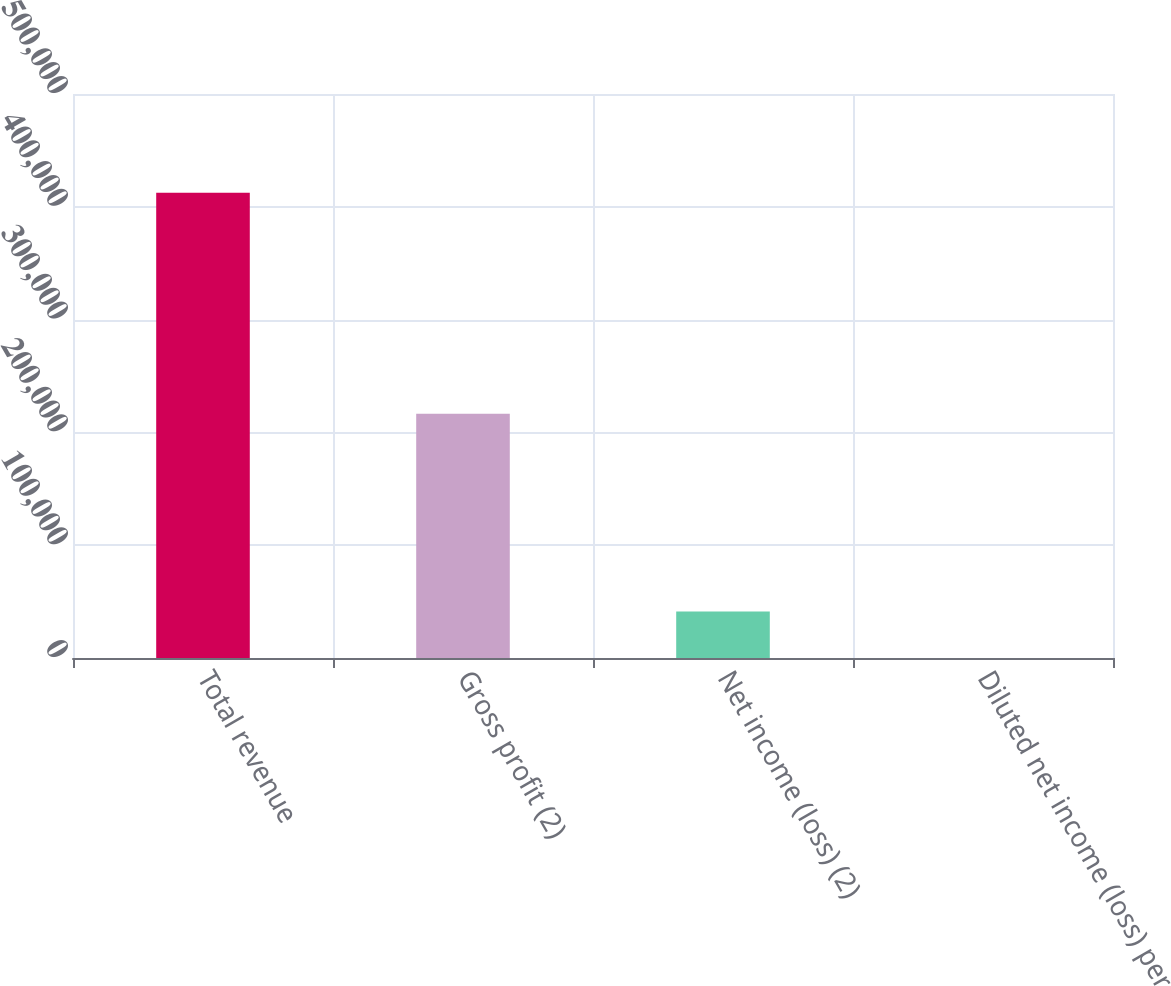Convert chart to OTSL. <chart><loc_0><loc_0><loc_500><loc_500><bar_chart><fcel>Total revenue<fcel>Gross profit (2)<fcel>Net income (loss) (2)<fcel>Diluted net income (loss) per<nl><fcel>412448<fcel>216445<fcel>41244.9<fcel>0.1<nl></chart> 